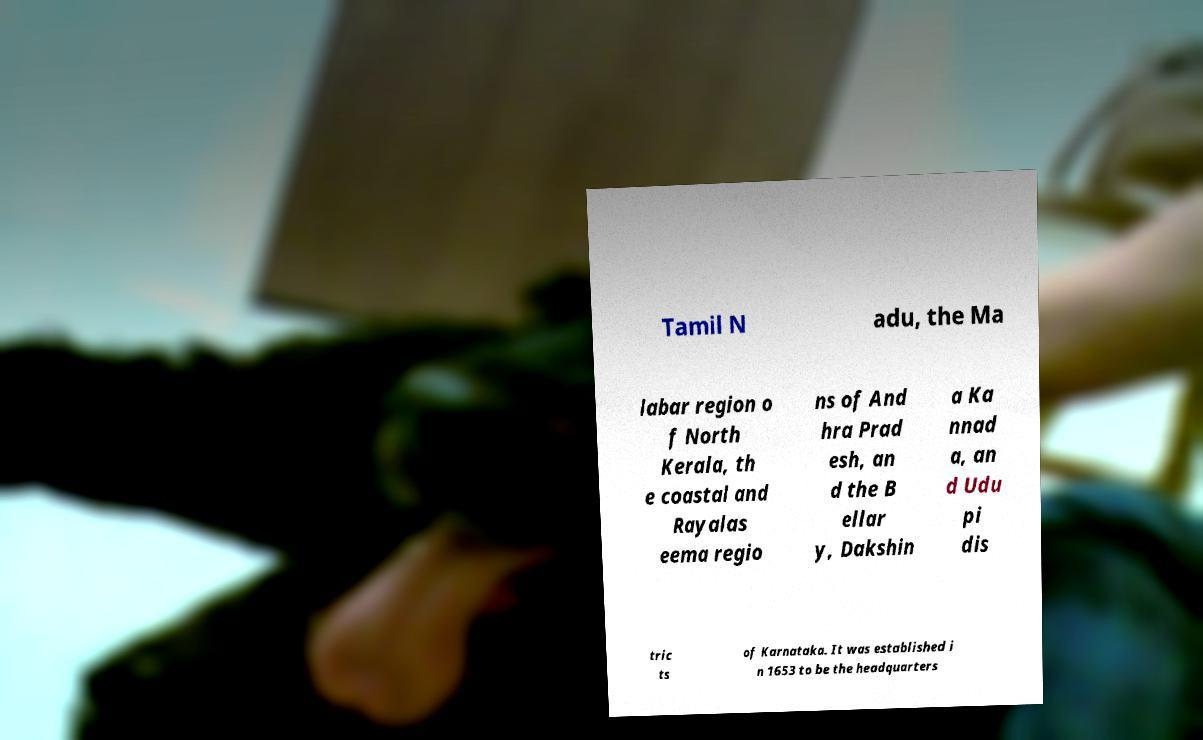There's text embedded in this image that I need extracted. Can you transcribe it verbatim? Tamil N adu, the Ma labar region o f North Kerala, th e coastal and Rayalas eema regio ns of And hra Prad esh, an d the B ellar y, Dakshin a Ka nnad a, an d Udu pi dis tric ts of Karnataka. It was established i n 1653 to be the headquarters 